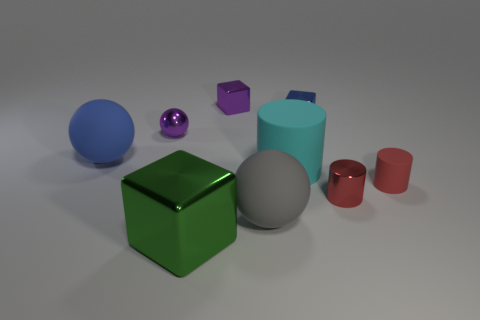Subtract all small metal blocks. How many blocks are left? 1 Subtract all blue spheres. How many spheres are left? 2 Subtract all cylinders. How many objects are left? 6 Subtract 2 cubes. How many cubes are left? 1 Subtract all blue cubes. How many blue cylinders are left? 0 Add 3 gray balls. How many gray balls exist? 4 Subtract 0 green cylinders. How many objects are left? 9 Subtract all red cylinders. Subtract all yellow blocks. How many cylinders are left? 1 Subtract all small cylinders. Subtract all small red matte cylinders. How many objects are left? 6 Add 5 big blue balls. How many big blue balls are left? 6 